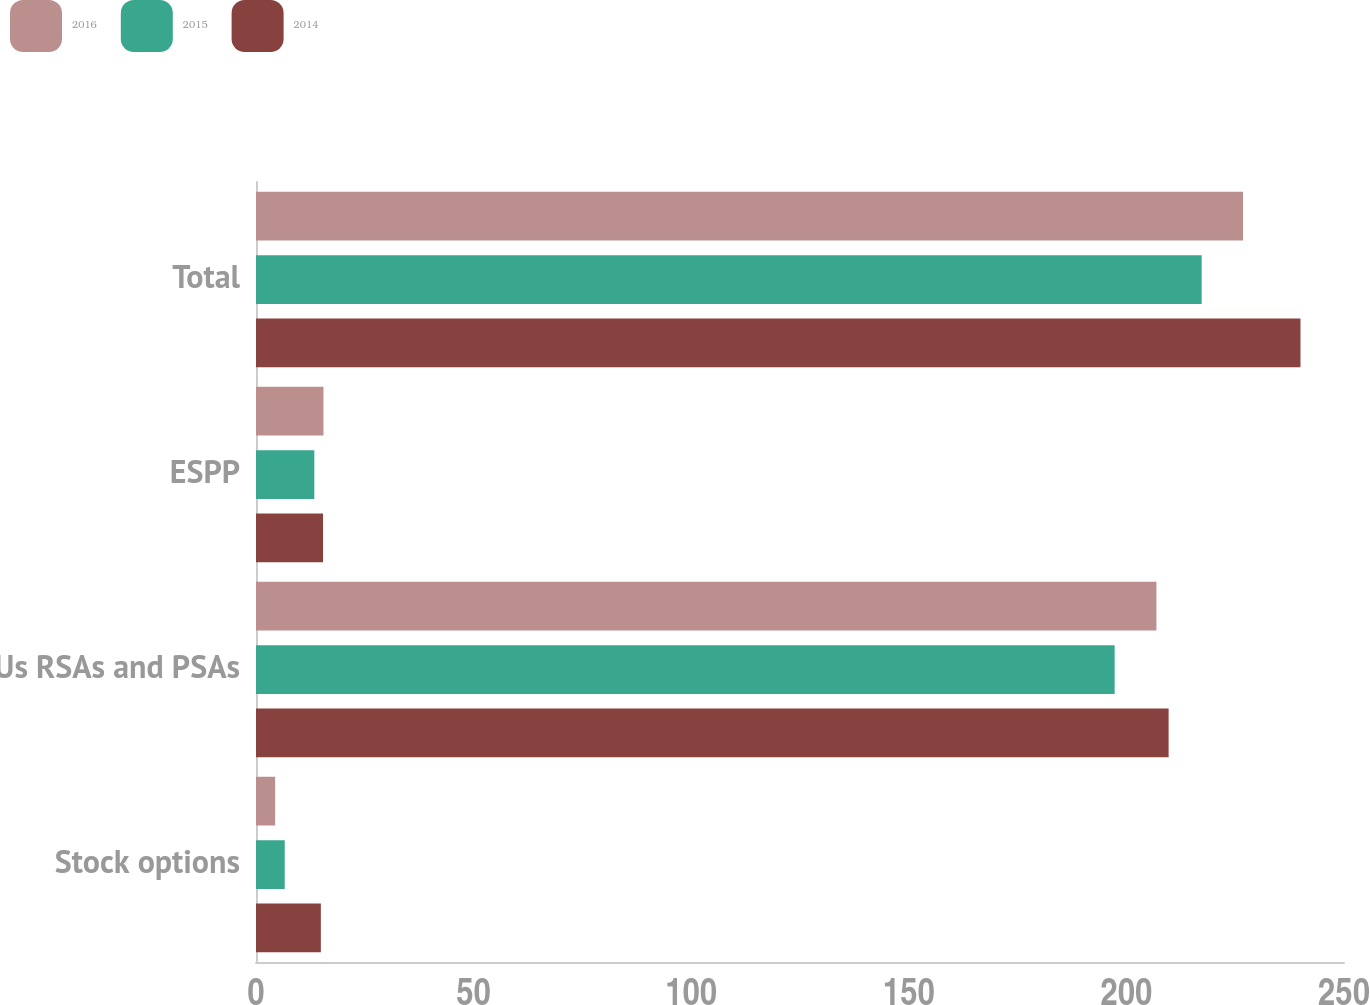Convert chart. <chart><loc_0><loc_0><loc_500><loc_500><stacked_bar_chart><ecel><fcel>Stock options<fcel>RSUs RSAs and PSAs<fcel>ESPP<fcel>Total<nl><fcel>2016<fcel>4.4<fcel>206.9<fcel>15.5<fcel>226.8<nl><fcel>2015<fcel>6.6<fcel>197.3<fcel>13.4<fcel>217.3<nl><fcel>2014<fcel>14.9<fcel>209.7<fcel>15.4<fcel>240<nl></chart> 